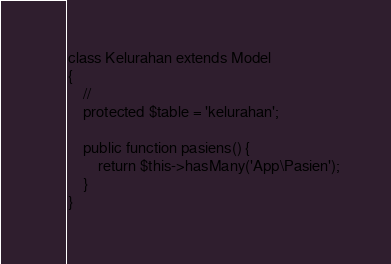Convert code to text. <code><loc_0><loc_0><loc_500><loc_500><_PHP_>
class Kelurahan extends Model
{
    //
    protected $table = 'kelurahan';

    public function pasiens() {
    	return $this->hasMany('App\Pasien');
    }
}
</code> 